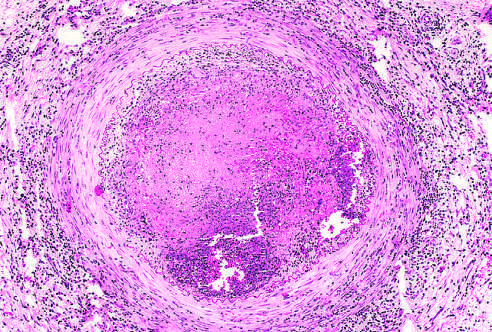s the lumen occluded by thrombus containing a sterile abscess?
Answer the question using a single word or phrase. Yes 